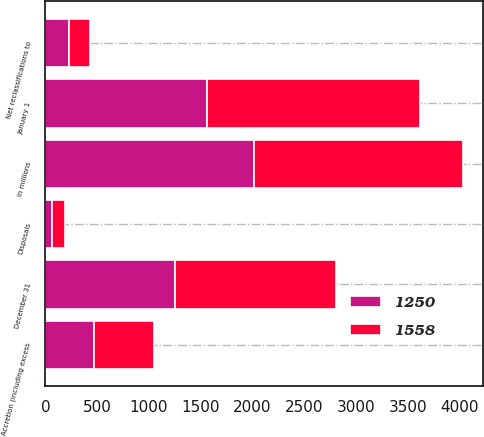Convert chart. <chart><loc_0><loc_0><loc_500><loc_500><stacked_bar_chart><ecel><fcel>In millions<fcel>January 1<fcel>Accretion (including excess<fcel>Net reclassifications to<fcel>Disposals<fcel>December 31<nl><fcel>1250<fcel>2015<fcel>1558<fcel>466<fcel>226<fcel>68<fcel>1250<nl><fcel>1558<fcel>2014<fcel>2055<fcel>587<fcel>208<fcel>118<fcel>1558<nl></chart> 